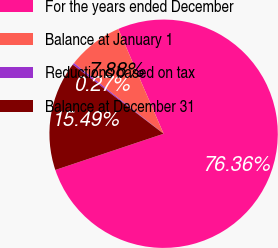Convert chart. <chart><loc_0><loc_0><loc_500><loc_500><pie_chart><fcel>For the years ended December<fcel>Balance at January 1<fcel>Reductions based on tax<fcel>Balance at December 31<nl><fcel>76.37%<fcel>7.88%<fcel>0.27%<fcel>15.49%<nl></chart> 